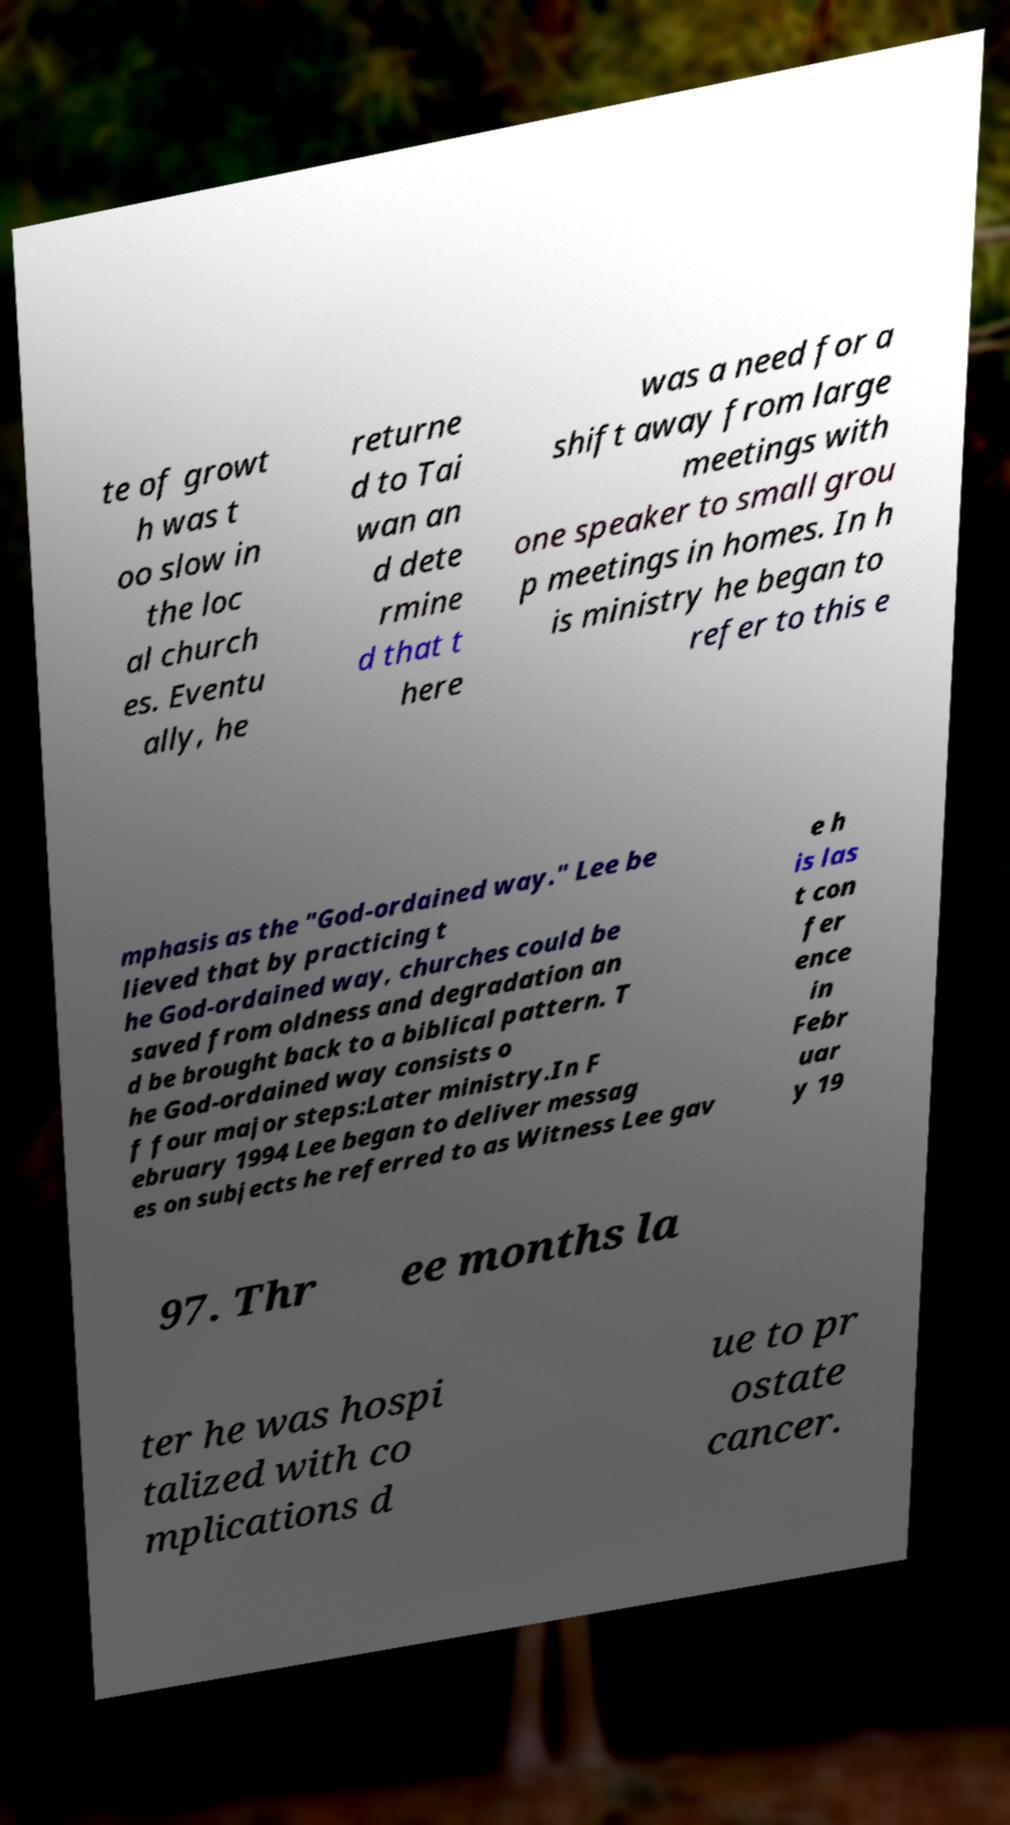I need the written content from this picture converted into text. Can you do that? te of growt h was t oo slow in the loc al church es. Eventu ally, he returne d to Tai wan an d dete rmine d that t here was a need for a shift away from large meetings with one speaker to small grou p meetings in homes. In h is ministry he began to refer to this e mphasis as the "God-ordained way." Lee be lieved that by practicing t he God-ordained way, churches could be saved from oldness and degradation an d be brought back to a biblical pattern. T he God-ordained way consists o f four major steps:Later ministry.In F ebruary 1994 Lee began to deliver messag es on subjects he referred to as Witness Lee gav e h is las t con fer ence in Febr uar y 19 97. Thr ee months la ter he was hospi talized with co mplications d ue to pr ostate cancer. 